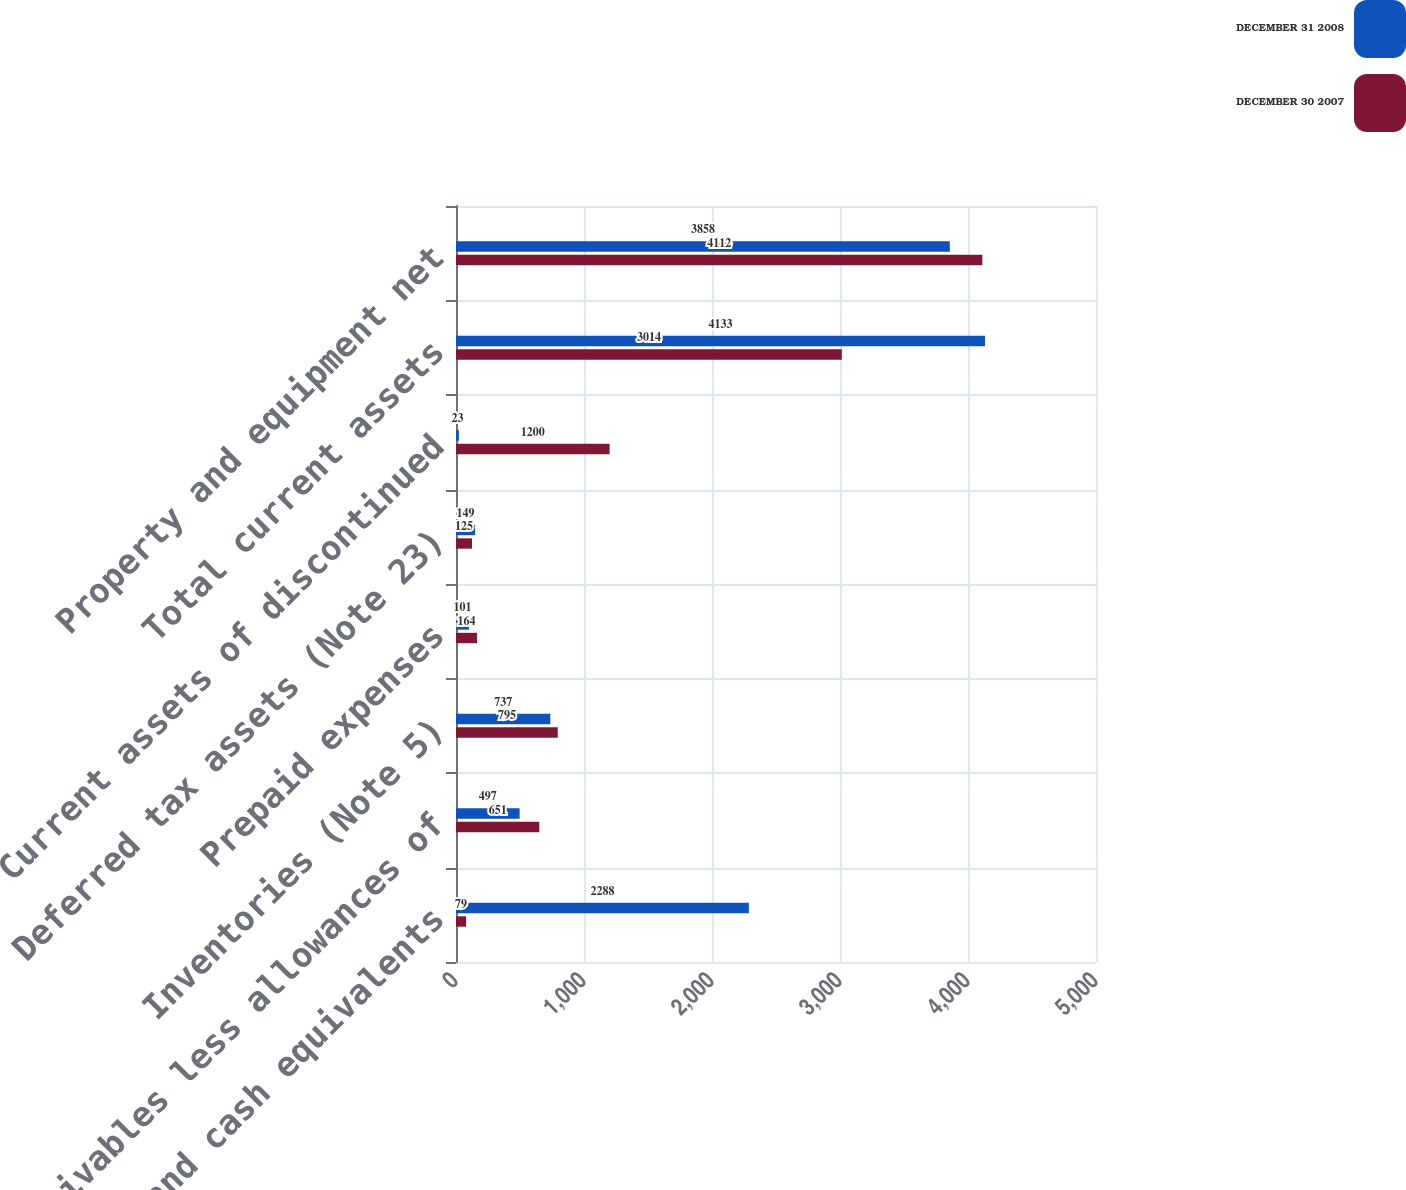Convert chart to OTSL. <chart><loc_0><loc_0><loc_500><loc_500><stacked_bar_chart><ecel><fcel>Cash and cash equivalents<fcel>Receivables less allowances of<fcel>Inventories (Note 5)<fcel>Prepaid expenses<fcel>Deferred tax assets (Note 23)<fcel>Current assets of discontinued<fcel>Total current assets<fcel>Property and equipment net<nl><fcel>DECEMBER 31 2008<fcel>2288<fcel>497<fcel>737<fcel>101<fcel>149<fcel>23<fcel>4133<fcel>3858<nl><fcel>DECEMBER 30 2007<fcel>79<fcel>651<fcel>795<fcel>164<fcel>125<fcel>1200<fcel>3014<fcel>4112<nl></chart> 